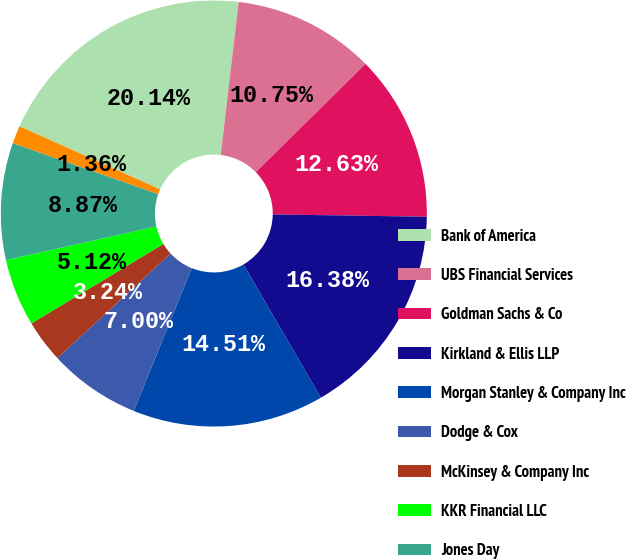<chart> <loc_0><loc_0><loc_500><loc_500><pie_chart><fcel>Bank of America<fcel>UBS Financial Services<fcel>Goldman Sachs & Co<fcel>Kirkland & Ellis LLP<fcel>Morgan Stanley & Company Inc<fcel>Dodge & Cox<fcel>McKinsey & Company Inc<fcel>KKR Financial LLC<fcel>Jones Day<fcel>Symphony Asset Management LLC<nl><fcel>20.14%<fcel>10.75%<fcel>12.63%<fcel>16.38%<fcel>14.51%<fcel>7.0%<fcel>3.24%<fcel>5.12%<fcel>8.87%<fcel>1.36%<nl></chart> 